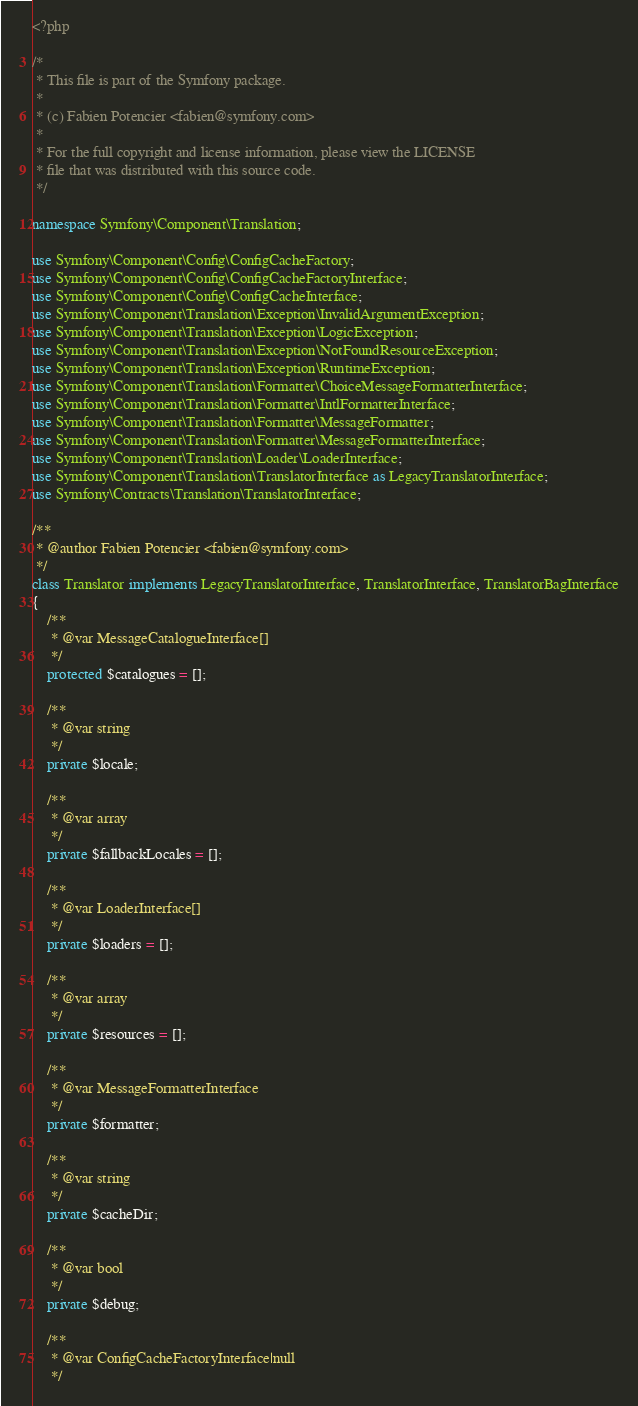Convert code to text. <code><loc_0><loc_0><loc_500><loc_500><_PHP_><?php

/*
 * This file is part of the Symfony package.
 *
 * (c) Fabien Potencier <fabien@symfony.com>
 *
 * For the full copyright and license information, please view the LICENSE
 * file that was distributed with this source code.
 */

namespace Symfony\Component\Translation;

use Symfony\Component\Config\ConfigCacheFactory;
use Symfony\Component\Config\ConfigCacheFactoryInterface;
use Symfony\Component\Config\ConfigCacheInterface;
use Symfony\Component\Translation\Exception\InvalidArgumentException;
use Symfony\Component\Translation\Exception\LogicException;
use Symfony\Component\Translation\Exception\NotFoundResourceException;
use Symfony\Component\Translation\Exception\RuntimeException;
use Symfony\Component\Translation\Formatter\ChoiceMessageFormatterInterface;
use Symfony\Component\Translation\Formatter\IntlFormatterInterface;
use Symfony\Component\Translation\Formatter\MessageFormatter;
use Symfony\Component\Translation\Formatter\MessageFormatterInterface;
use Symfony\Component\Translation\Loader\LoaderInterface;
use Symfony\Component\Translation\TranslatorInterface as LegacyTranslatorInterface;
use Symfony\Contracts\Translation\TranslatorInterface;

/**
 * @author Fabien Potencier <fabien@symfony.com>
 */
class Translator implements LegacyTranslatorInterface, TranslatorInterface, TranslatorBagInterface
{
    /**
     * @var MessageCatalogueInterface[]
     */
    protected $catalogues = [];

    /**
     * @var string
     */
    private $locale;

    /**
     * @var array
     */
    private $fallbackLocales = [];

    /**
     * @var LoaderInterface[]
     */
    private $loaders = [];

    /**
     * @var array
     */
    private $resources = [];

    /**
     * @var MessageFormatterInterface
     */
    private $formatter;

    /**
     * @var string
     */
    private $cacheDir;

    /**
     * @var bool
     */
    private $debug;

    /**
     * @var ConfigCacheFactoryInterface|null
     */</code> 